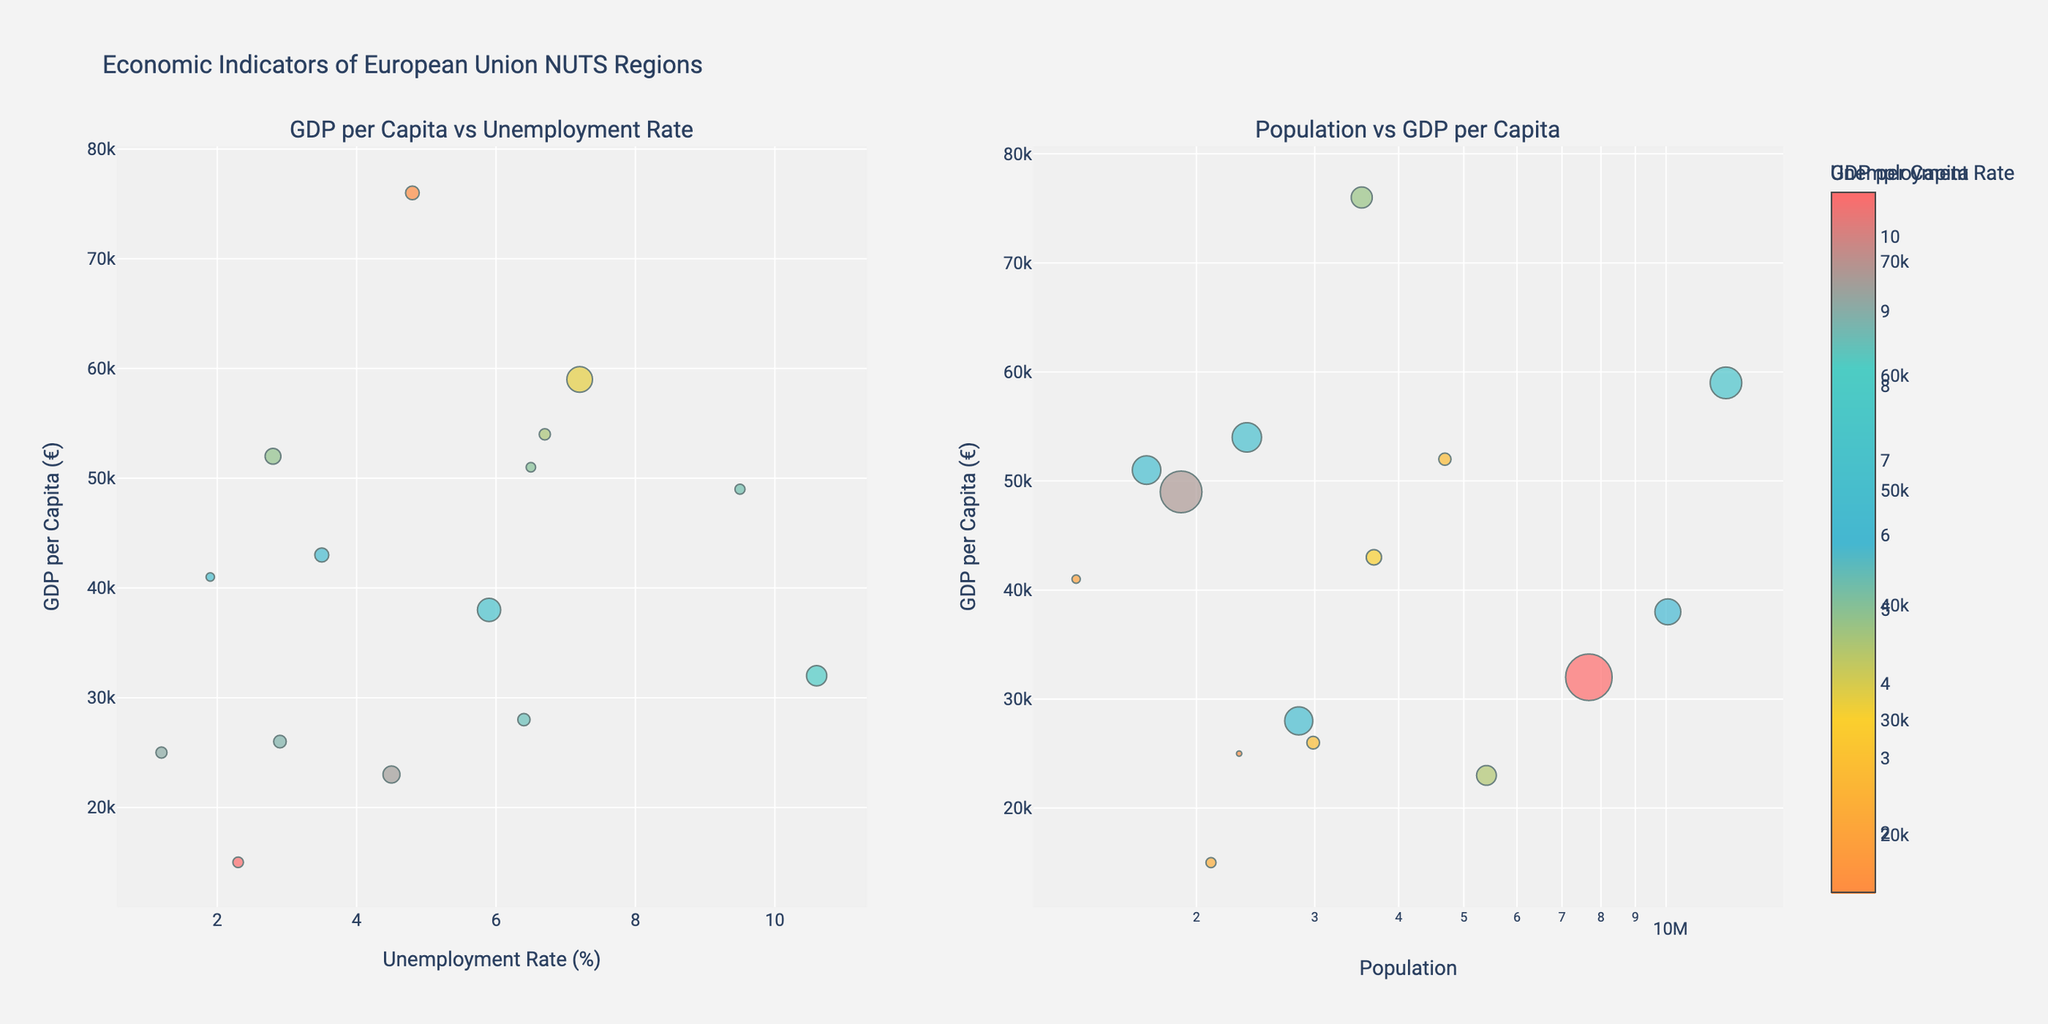What is the title of the figure? The title of the figure is typically located at the top center of the plot and provides a summary of what the figure represents.
Answer: Relationship between Marketing Spend and Event Turnout How many different event categories are presented in the figure? The figure includes subplots for each unique 'Event Category'. Counting the different titles above each subplot, we can find the number of categories.
Answer: 5 What is the highest marketing spend observable for the 'Music Festival' category and what is its corresponding turnout? By checking the subplot titled 'Music Festival', we look at the maximum x-value (Marketing Spend) and find the corresponding y-value (Attendees). The highest marketing spend is $125,000, and its corresponding turnout is 35,000 attendees.
Answer: $125,000, 35,000 attendees Which event category has the lowest maximum number of attendees? By comparing the maximum y-values (Attendees) across all subplots, we look for the lowest maximum attendee count. The 'Heritage Tour' category has the lowest maximum number of attendees, which is 4,500.
Answer: Heritage Tour What trend can be observed between Marketing Spend and Attendees for 'Cultural Exhibition'? Observing the trendline in the subplot for 'Cultural Exhibition', we can see if there is an increasing or decreasing trend. The trend shows that as marketing spend increases, the number of attendees also increases, indicating a positive correlation.
Answer: Positive correlation Between 'Food & Wine Fair' and 'Local Art Show', which event category shows a greater increase in attendees with increasing marketing spend? By comparing the slopes of the trendlines in the 'Food & Wine Fair' and 'Local Art Show' subplots, we determine which trendline has a steeper upward slope. The 'Food & Wine Fair' shows a greater increase in attendees with increasing marketing spend.
Answer: Food & Wine Fair What is the average number of attendees for the 'Heritage Tour' category? We add the number of attendees for each data point in the 'Heritage Tour' subplot and divide the total by the number of data points. The attendees are 1,500, 2,500, 3,500, and 4,500, so (1,500 + 2,500 + 3,500 + 4,500) / 4 = 3,000.
Answer: 3,000 Are there any outliers in terms of event turnout for any category? By inspecting each subplot, we identify any data points that deviate significantly from the trendline. In this figure, there are no significant outliers for any of the categories.
Answer: No How does the 'Local Art Show' category compare in terms of attendee count range to the 'Music Festival' category? By comparing the range of y-values (Attendees) in both subplots, we find the range for 'Local Art Show' (2,000 to 6,500) is much smaller than the range for 'Music Festival' (15,000 to 35,000).
Answer: Smaller range What is the effect of increasing marketing spend on attendees for 'Local Art Show'? By examining the trendline in the 'Local Art Show' subplot, we observe that attendees increase as marketing spend increases, but the rate of increase is less steep compared to other categories such as 'Music Festival'.
Answer: Increase with smaller rate 